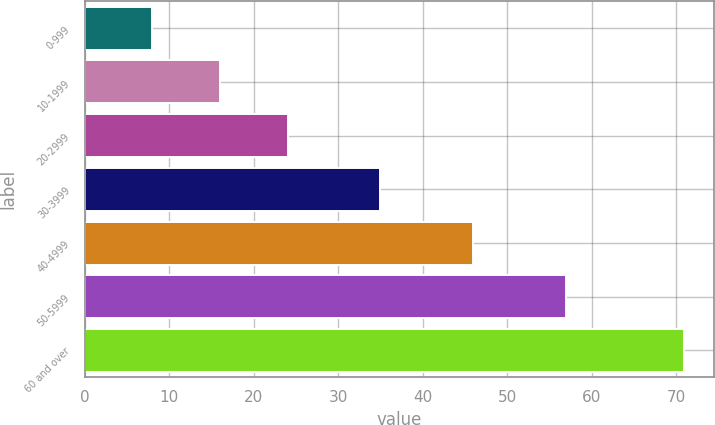Convert chart to OTSL. <chart><loc_0><loc_0><loc_500><loc_500><bar_chart><fcel>0-999<fcel>10-1999<fcel>20-2999<fcel>30-3999<fcel>40-4999<fcel>50-5999<fcel>60 and over<nl><fcel>8<fcel>16<fcel>24<fcel>35<fcel>46<fcel>57<fcel>71<nl></chart> 